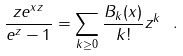<formula> <loc_0><loc_0><loc_500><loc_500>\frac { z e ^ { x z } } { e ^ { z } - 1 } = \sum _ { k \geq 0 } \frac { B _ { k } ( x ) } { k ! } z ^ { k } \ .</formula> 